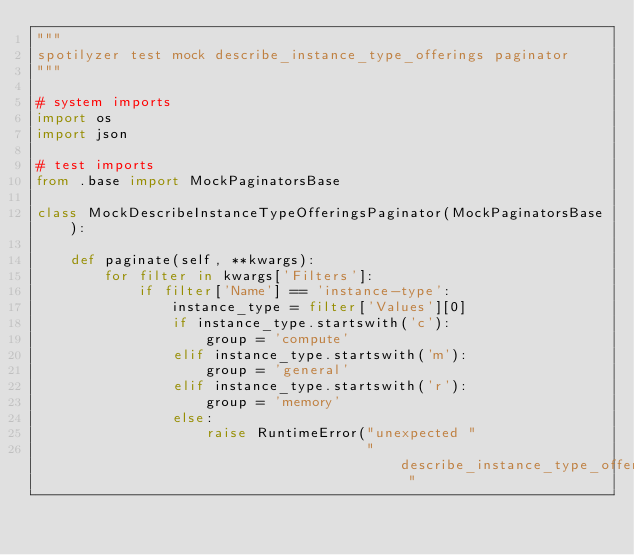<code> <loc_0><loc_0><loc_500><loc_500><_Python_>"""
spotilyzer test mock describe_instance_type_offerings paginator
"""

# system imports
import os
import json

# test imports
from .base import MockPaginatorsBase

class MockDescribeInstanceTypeOfferingsPaginator(MockPaginatorsBase):

    def paginate(self, **kwargs):
        for filter in kwargs['Filters']:
            if filter['Name'] == 'instance-type':
                instance_type = filter['Values'][0]
                if instance_type.startswith('c'):
                    group = 'compute'
                elif instance_type.startswith('m'):
                    group = 'general'
                elif instance_type.startswith('r'):
                    group = 'memory'
                else:
                    raise RuntimeError("unexpected "
                                       "describe_instance_type_offerings "</code> 